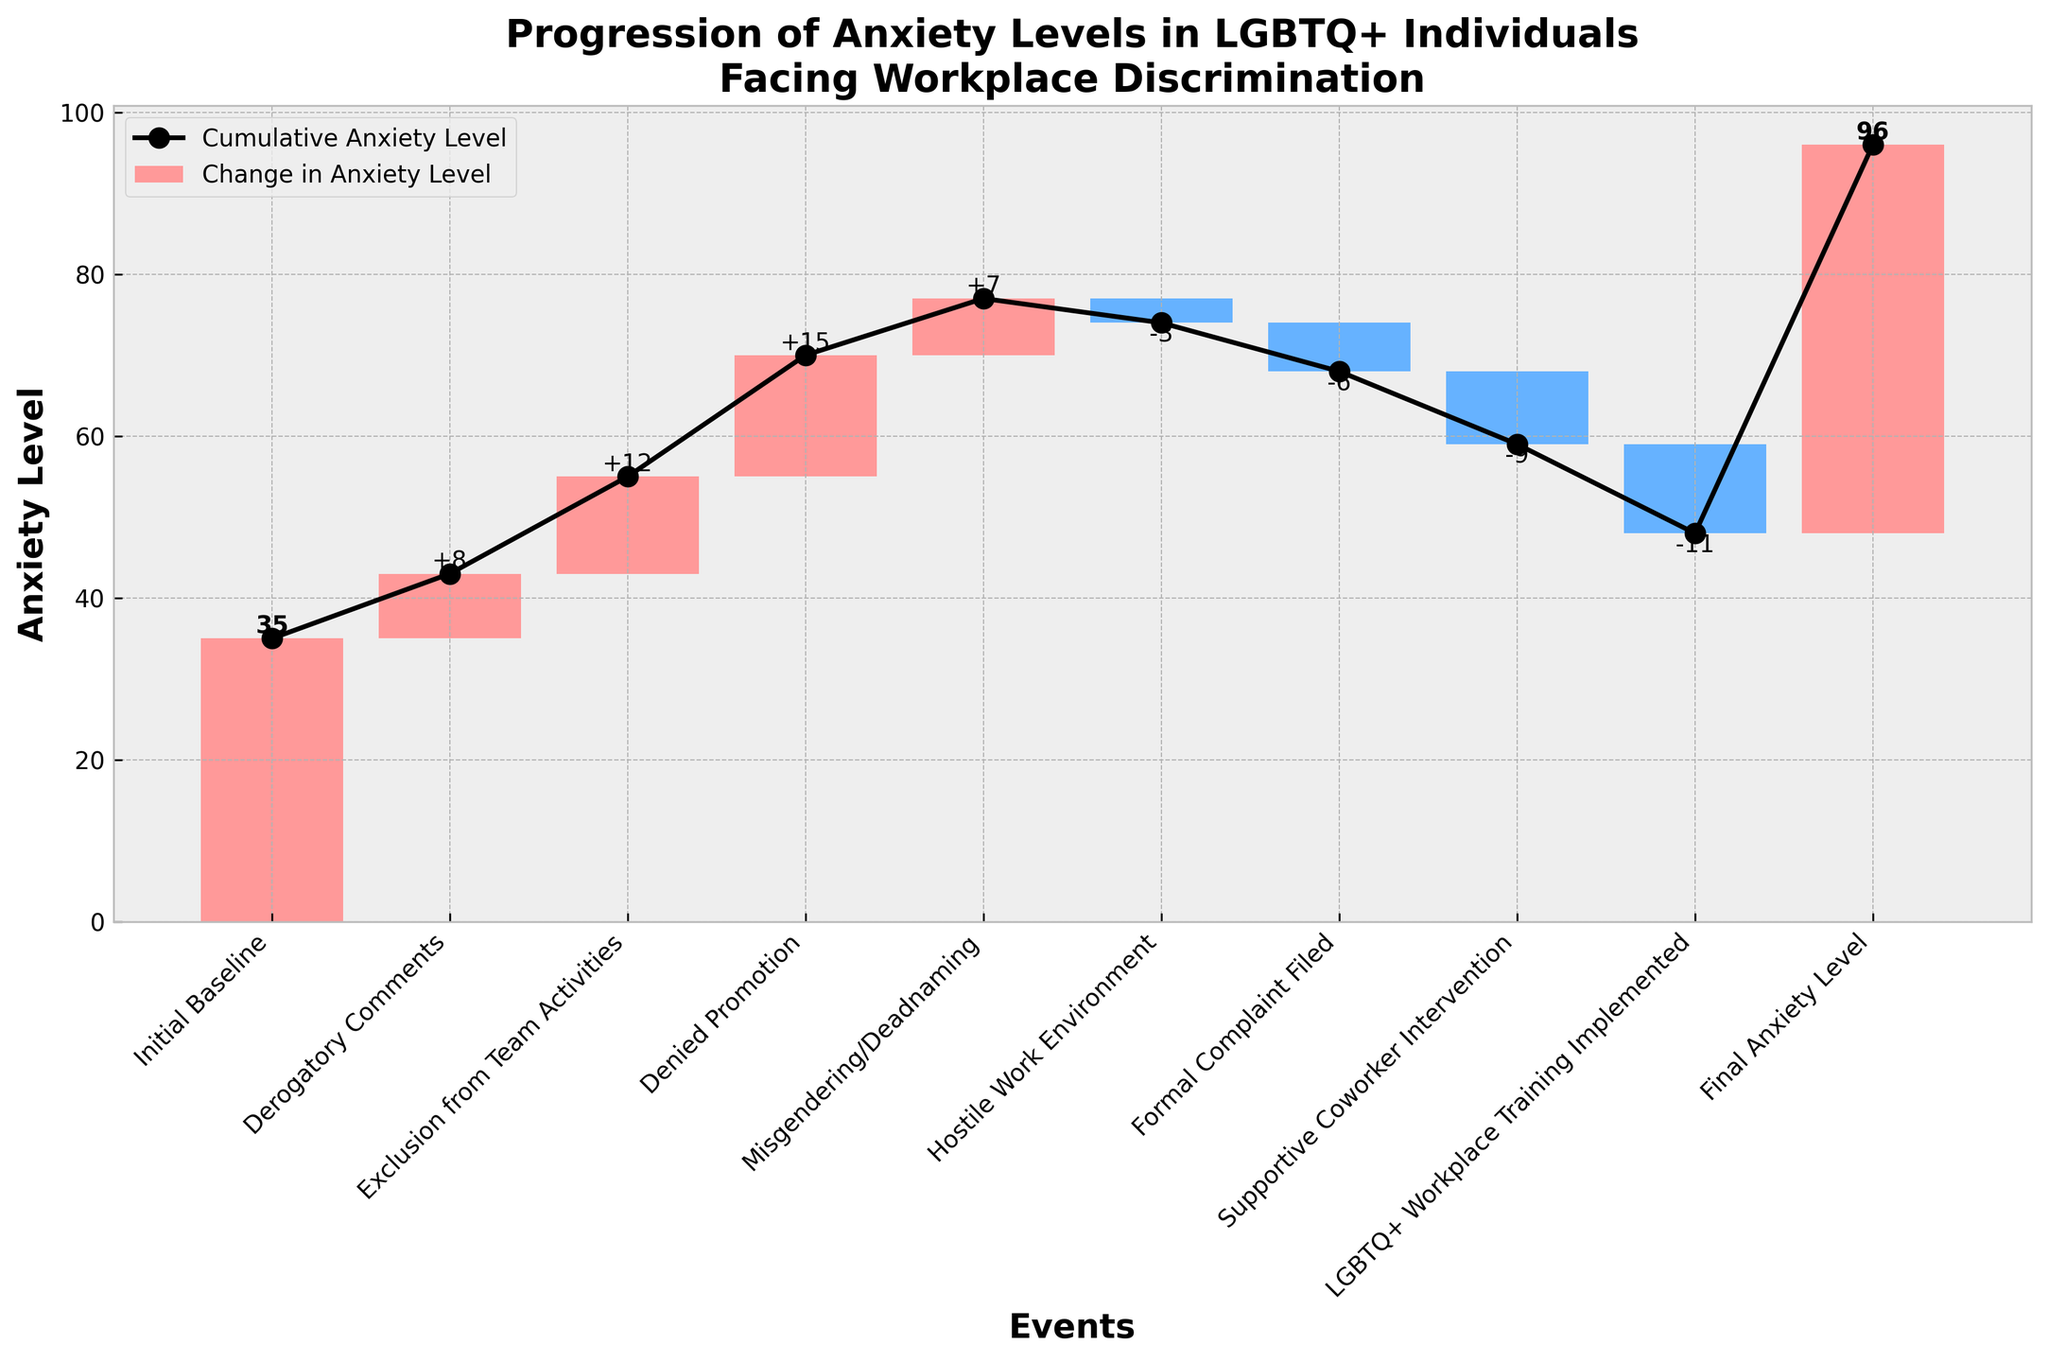What's the title of the chart? The title of the chart is usually prominently displayed at the top and summarizes what the chart is about. For this chart, it states: "Progression of Anxiety Levels in LGBTQ+ Individuals Facing Workplace Discrimination".
Answer: Progression of Anxiety Levels in LGBTQ+ Individuals Facing Workplace Discrimination What does the x-axis represent? The x-axis typically identifies the different categories or events being tracked over time in a waterfall chart. For this chart, each tick mark corresponds to a specific event experienced by LGBTQ+ individuals, such as "Derogatory Comments" or "Supportive Coworker Intervention".
Answer: Events What is the final anxiety level shown in the chart? To find the final anxiety level, look at the cumulative anxiety level plotted in black markers along the line at the last event. The final event is "Final Anxiety Level", where the cumulative anxiety level reaches 48.
Answer: 48 Which event is associated with the largest increase in anxiety levels? By observing the height of the bars that extend upward, we can see the largest increase. "Denied Promotion" has the largest positive change in anxiety level by +15.
Answer: Denied Promotion What was the cumulative anxiety level after "Exclusion from Team Activities"? To determine the cumulative anxiety level after the "Exclusion from Team Activities" event, refer to the cumulative line marking at that specific event. The cumulative can be obtained around 35 + 8 + 12 = 55.
Answer: 55 What are the colors representing in this chart? Waterfall charts often use colors to differentiate between positive and negative changes. In this chart, red bars represent increases in anxiety levels, and blue bars represent decreases.
Answer: Red for increases, blue for decreases Calculate the total increase in anxiety levels due to negative events. Summing up the changes in anxiety levels for all negative events (where the bar goes up): Derogatory Comments (+8), Exclusion from Team Activities (+12), Denied Promotion (+15), and Misgendering/Deadnaming (+7). Total = 8 + 12 + 15 + 7 = 42.
Answer: 42 Which event resulted in the greatest reduction in anxiety levels? By looking at the lengths of the blue bars that extend downwards signifying reductions, "LGBTQ+ Workplace Training Implemented" results in the greatest reduction by -11.
Answer: LGBTQ+ Workplace Training Implemented Compare the cumulative anxiety level before and after "Hostile Work Environment". Before "Hostile Work Environment", the cumulative anxiety was around 35 + 8 + 12 + 15 + 7 = 77. After it, the cumulative anxiety is 77 - 3 = 74.
Answer: Before: 77, After: 74 